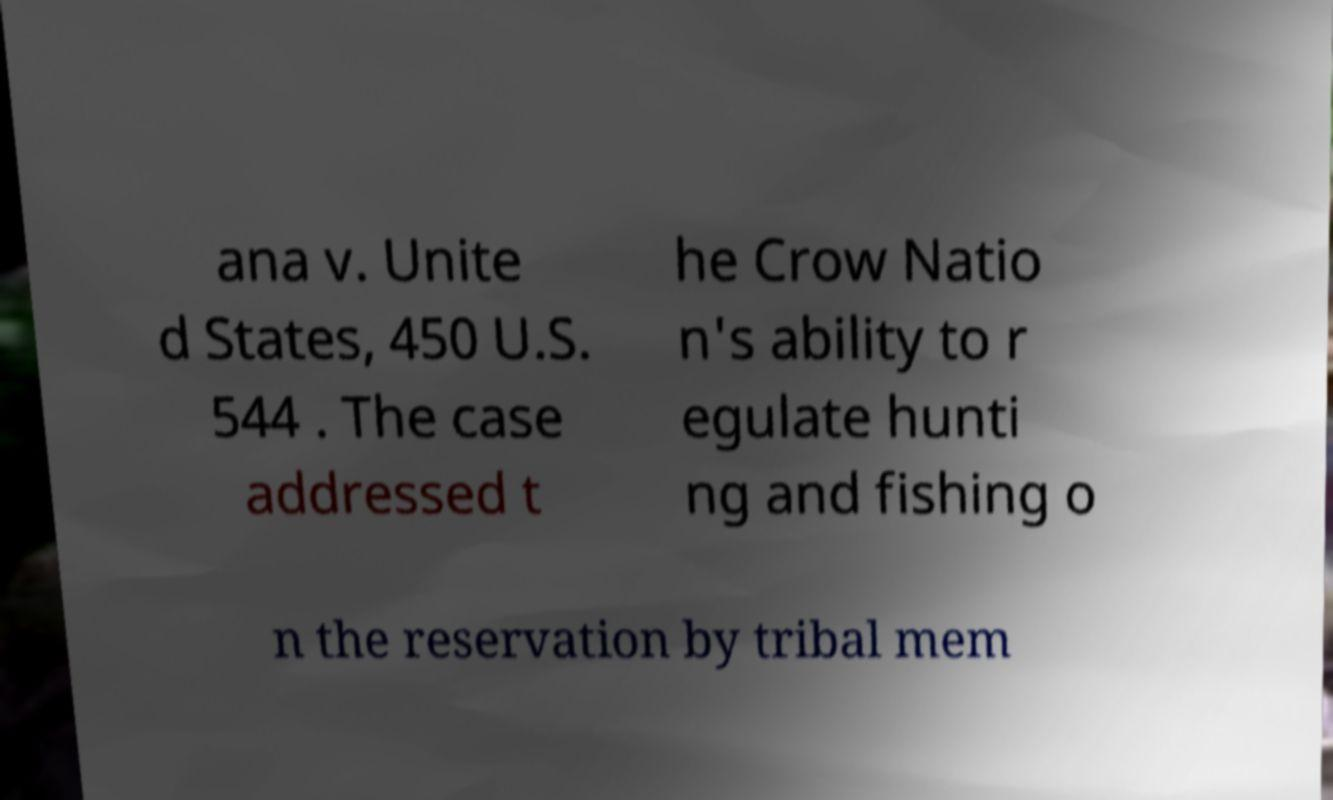For documentation purposes, I need the text within this image transcribed. Could you provide that? ana v. Unite d States, 450 U.S. 544 . The case addressed t he Crow Natio n's ability to r egulate hunti ng and fishing o n the reservation by tribal mem 